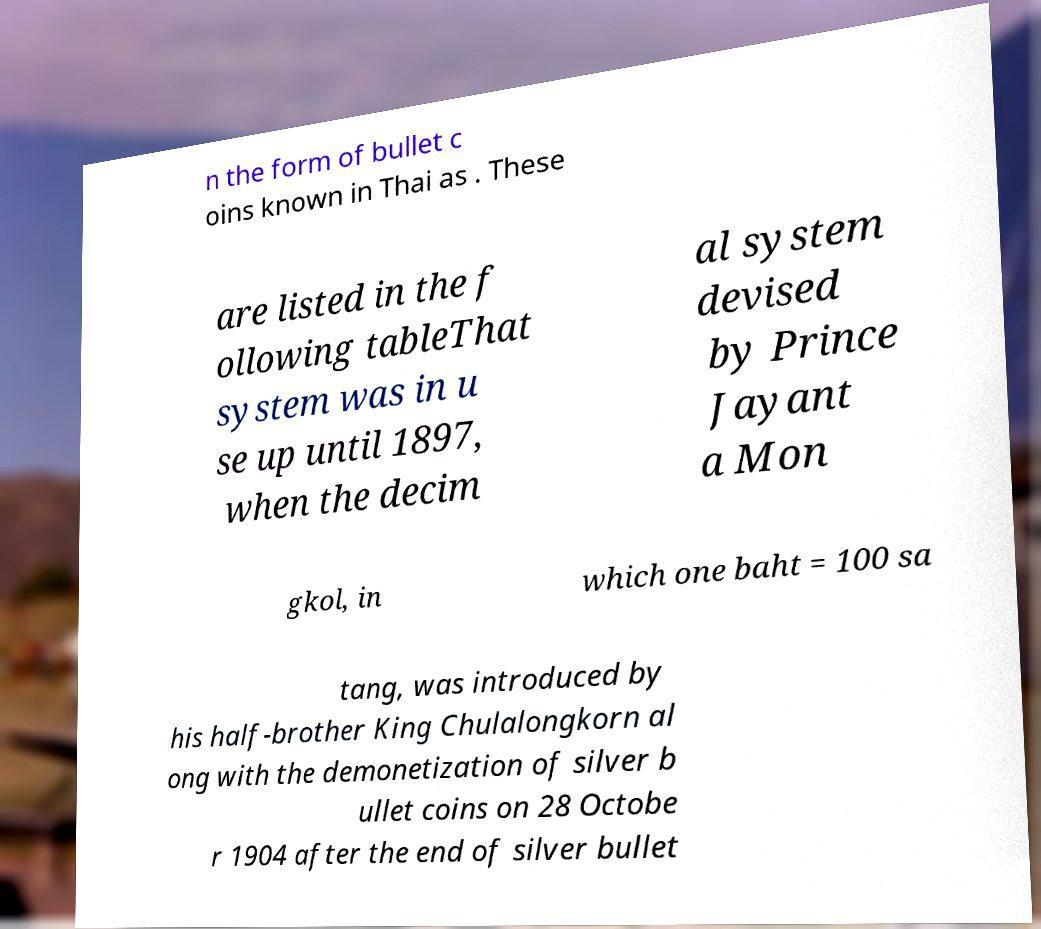I need the written content from this picture converted into text. Can you do that? n the form of bullet c oins known in Thai as . These are listed in the f ollowing tableThat system was in u se up until 1897, when the decim al system devised by Prince Jayant a Mon gkol, in which one baht = 100 sa tang, was introduced by his half-brother King Chulalongkorn al ong with the demonetization of silver b ullet coins on 28 Octobe r 1904 after the end of silver bullet 